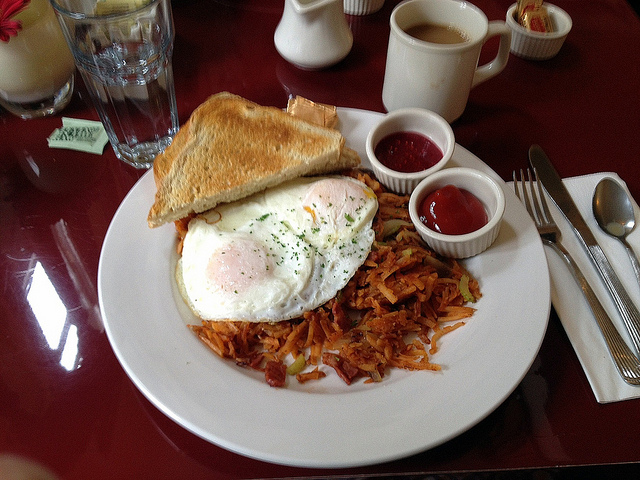If this breakfast could talk, what would it say about its ingredients? Good morning! Every element on this plate has a story. The eggs, laid by happy free-range hens, are proud to be here, ready to offer their delicious yolk and whites. The crispy hash browns are made from potatoes grown with love in rich, fertile soil, promising a delightful crunch with every bite. The toast is crafted from freshly baked bread, whose wheat was harvested under the warm summer sun. As for the bright red and fruity jam, it's made from ripe berries that were picked at just the right moment of sweetness. Each ingredient is thrilled to come together on this plate to create a harmonious and tasty start to your day. It sounds like a harmonious gathering of ingredients! Absolutely! Each ingredient brings its own unique character to the meal, creating a symphony of flavors and textures. It's not just about nourishment; it's about celebrating the journey from farm to table and savoring the goodness life has to offer. Enjoy every bite! 